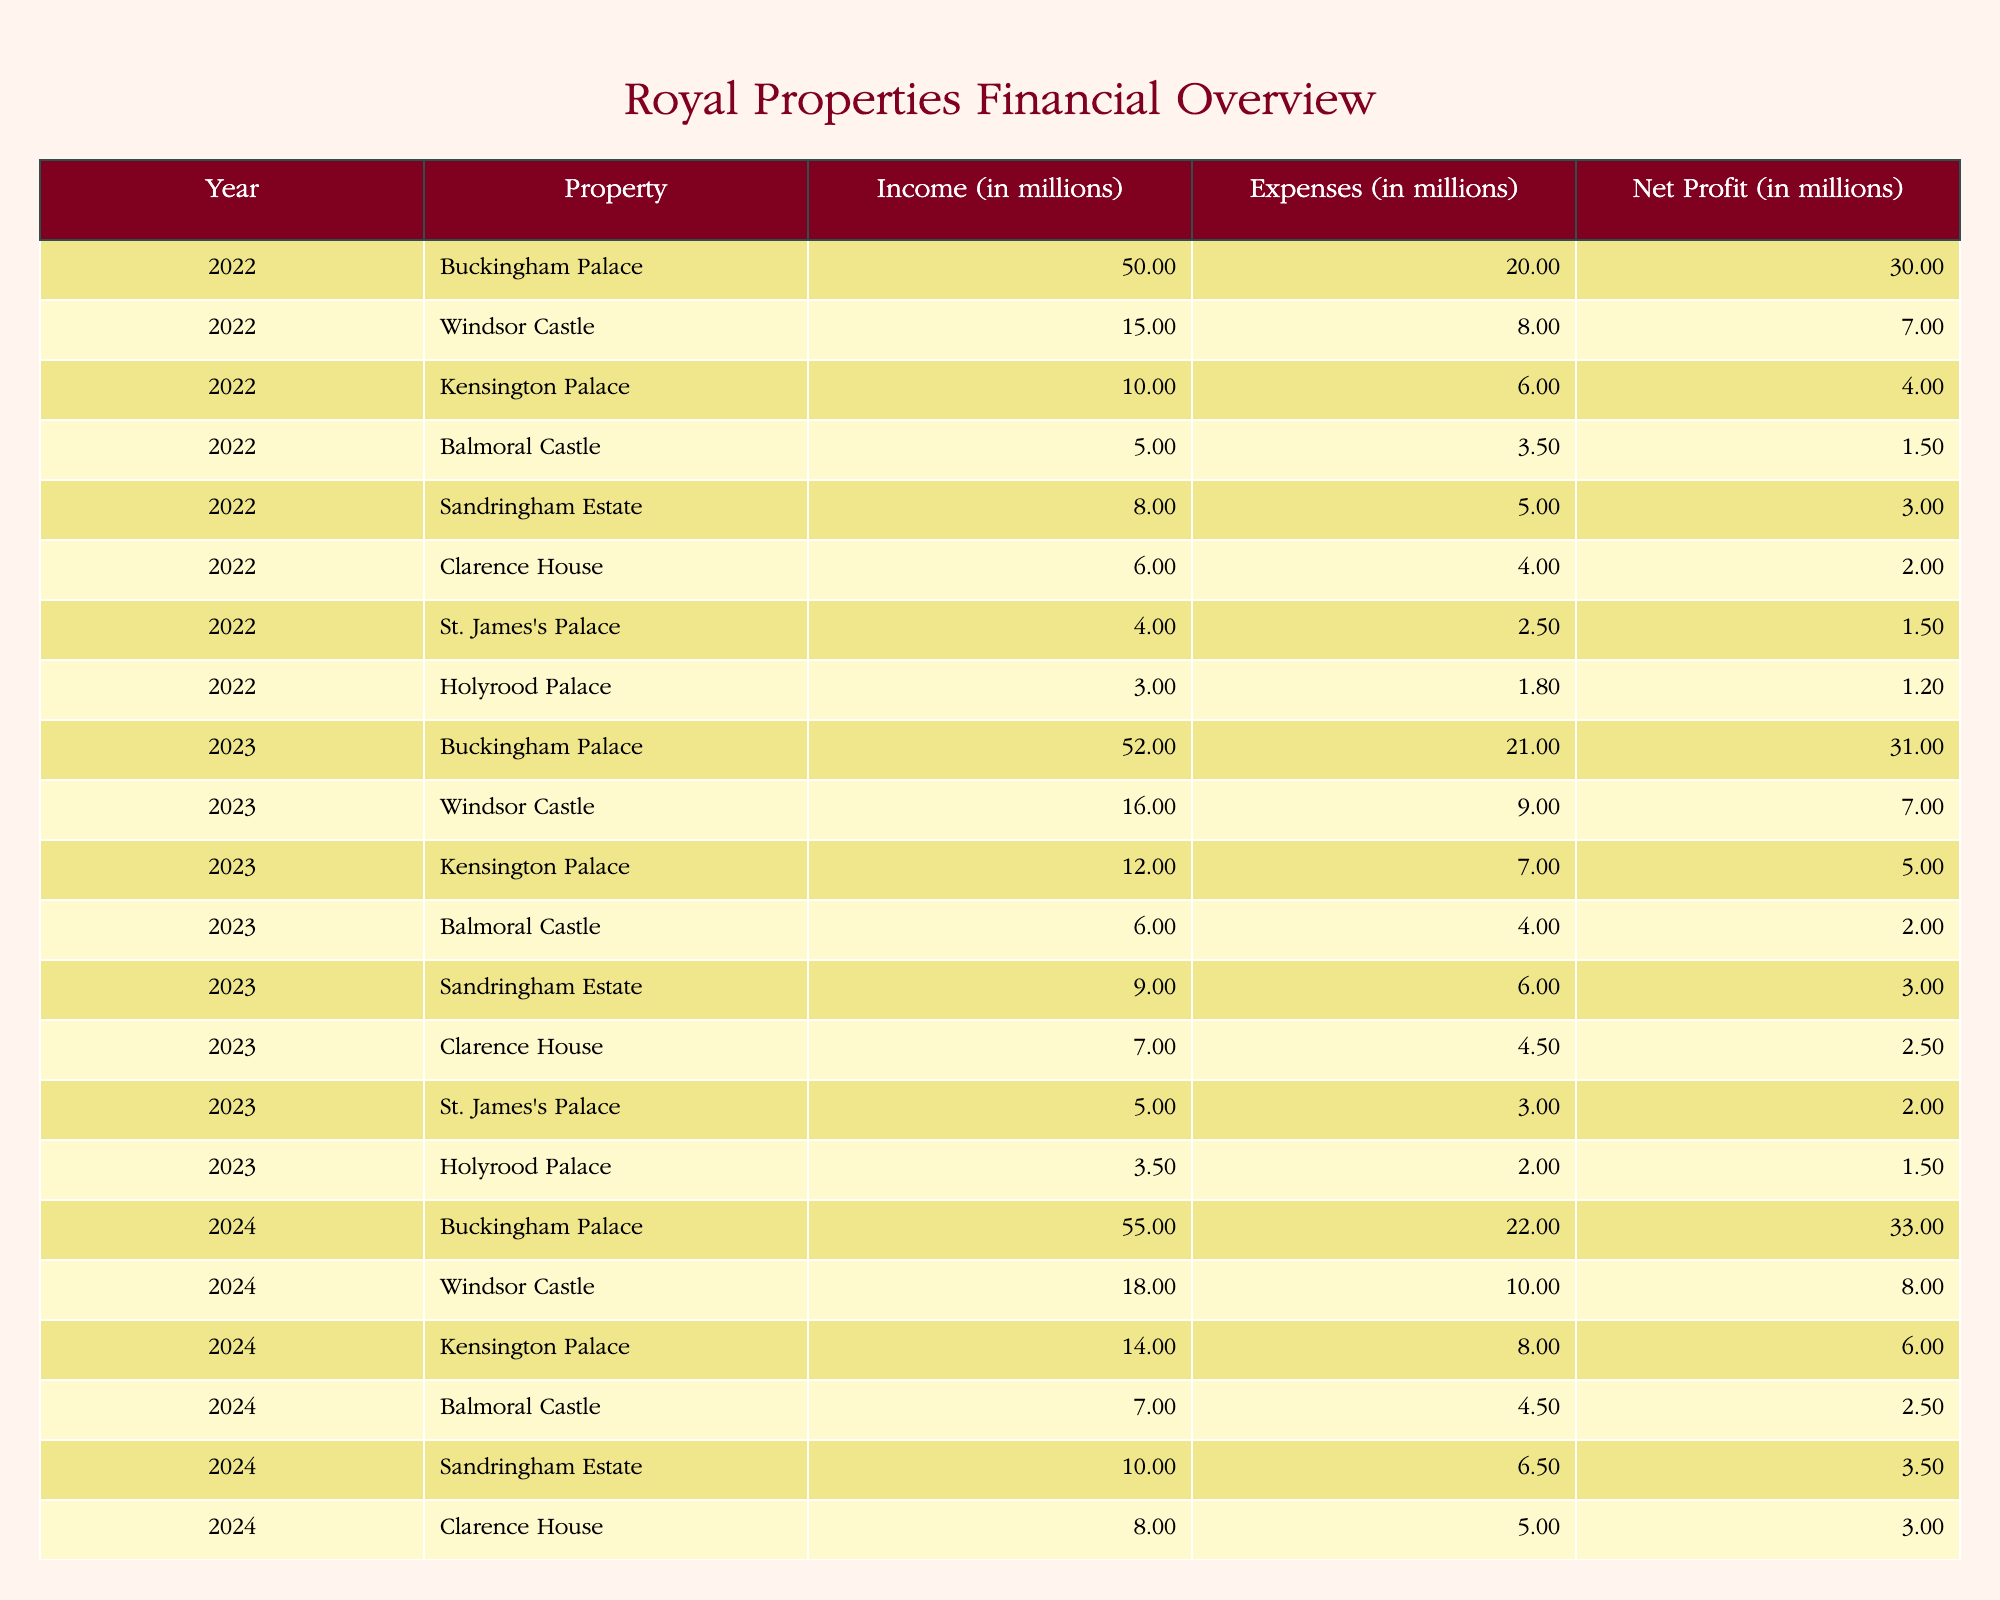What was the net profit for Windsor Castle in 2023? The table shows that in 2023, Windsor Castle had a net profit of 7 million.
Answer: 7 million What is the total income generated by Buckingham Palace from 2022 to 2024? To find the total income from Buckingham Palace over these years, we add the income values: 50 million (2022) + 52 million (2023) + 55 million (2024) = 157 million.
Answer: 157 million Is the net profit for Kensington Palace in 2024 higher than in 2022? The net profit for Kensington Palace in 2024 is 6 million, while in 2022 it was 4 million. Since 6 million is greater than 4 million, the statement is true.
Answer: Yes What was the percentage increase in net profit for Balmoral Castle from 2022 to 2024? The net profit for Balmoral Castle in 2022 was 1.5 million and in 2024 it was 2.5 million. The increase is 2.5 million - 1.5 million = 1 million. The percentage increase is (1 million / 1.5 million) * 100 = 66.67%.
Answer: 66.67% Which property had the highest net profit in 2024? According to the table, Buckingham Palace had the highest net profit in 2024, which was 33 million.
Answer: Buckingham Palace What was the average expenses for Holyrood Palace over the three years? The expenses for Holyrood Palace are: 1.8 million (2022), 2 million (2023), and 2.2 million (2024). The sum of expenses is 1.8 million + 2 million + 2.2 million = 6 million. To find the average, divide by 3: 6 million / 3 = 2 million.
Answer: 2 million Did Clarence House operate at a loss in any of the years? By examining the net profit for Clarence House, which was 2 million (2022), 2.5 million (2023), and 3 million (2024), we find that all values are positive. Thus, Clarence House did not operate at a loss in any year.
Answer: No What is the total net profit from Sandringham Estate across all reported years? The net profits for Sandringham Estate are: 3 million (2022) + 3 million (2023) + 3.5 million (2024) = 9.5 million.
Answer: 9.5 million 